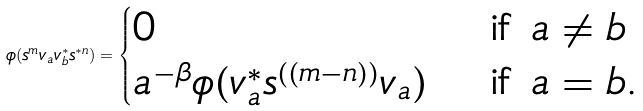Convert formula to latex. <formula><loc_0><loc_0><loc_500><loc_500>\phi ( s ^ { m } v _ { a } v _ { b } ^ { * } s ^ { * n } ) = \begin{cases} 0 & \text { if $a\neq b$} \\ a ^ { - \beta } \phi ( v _ { a } ^ { * } s ^ { ( ( m - n ) ) } v _ { a } ) & \text { if $a= b$.} \end{cases}</formula> 